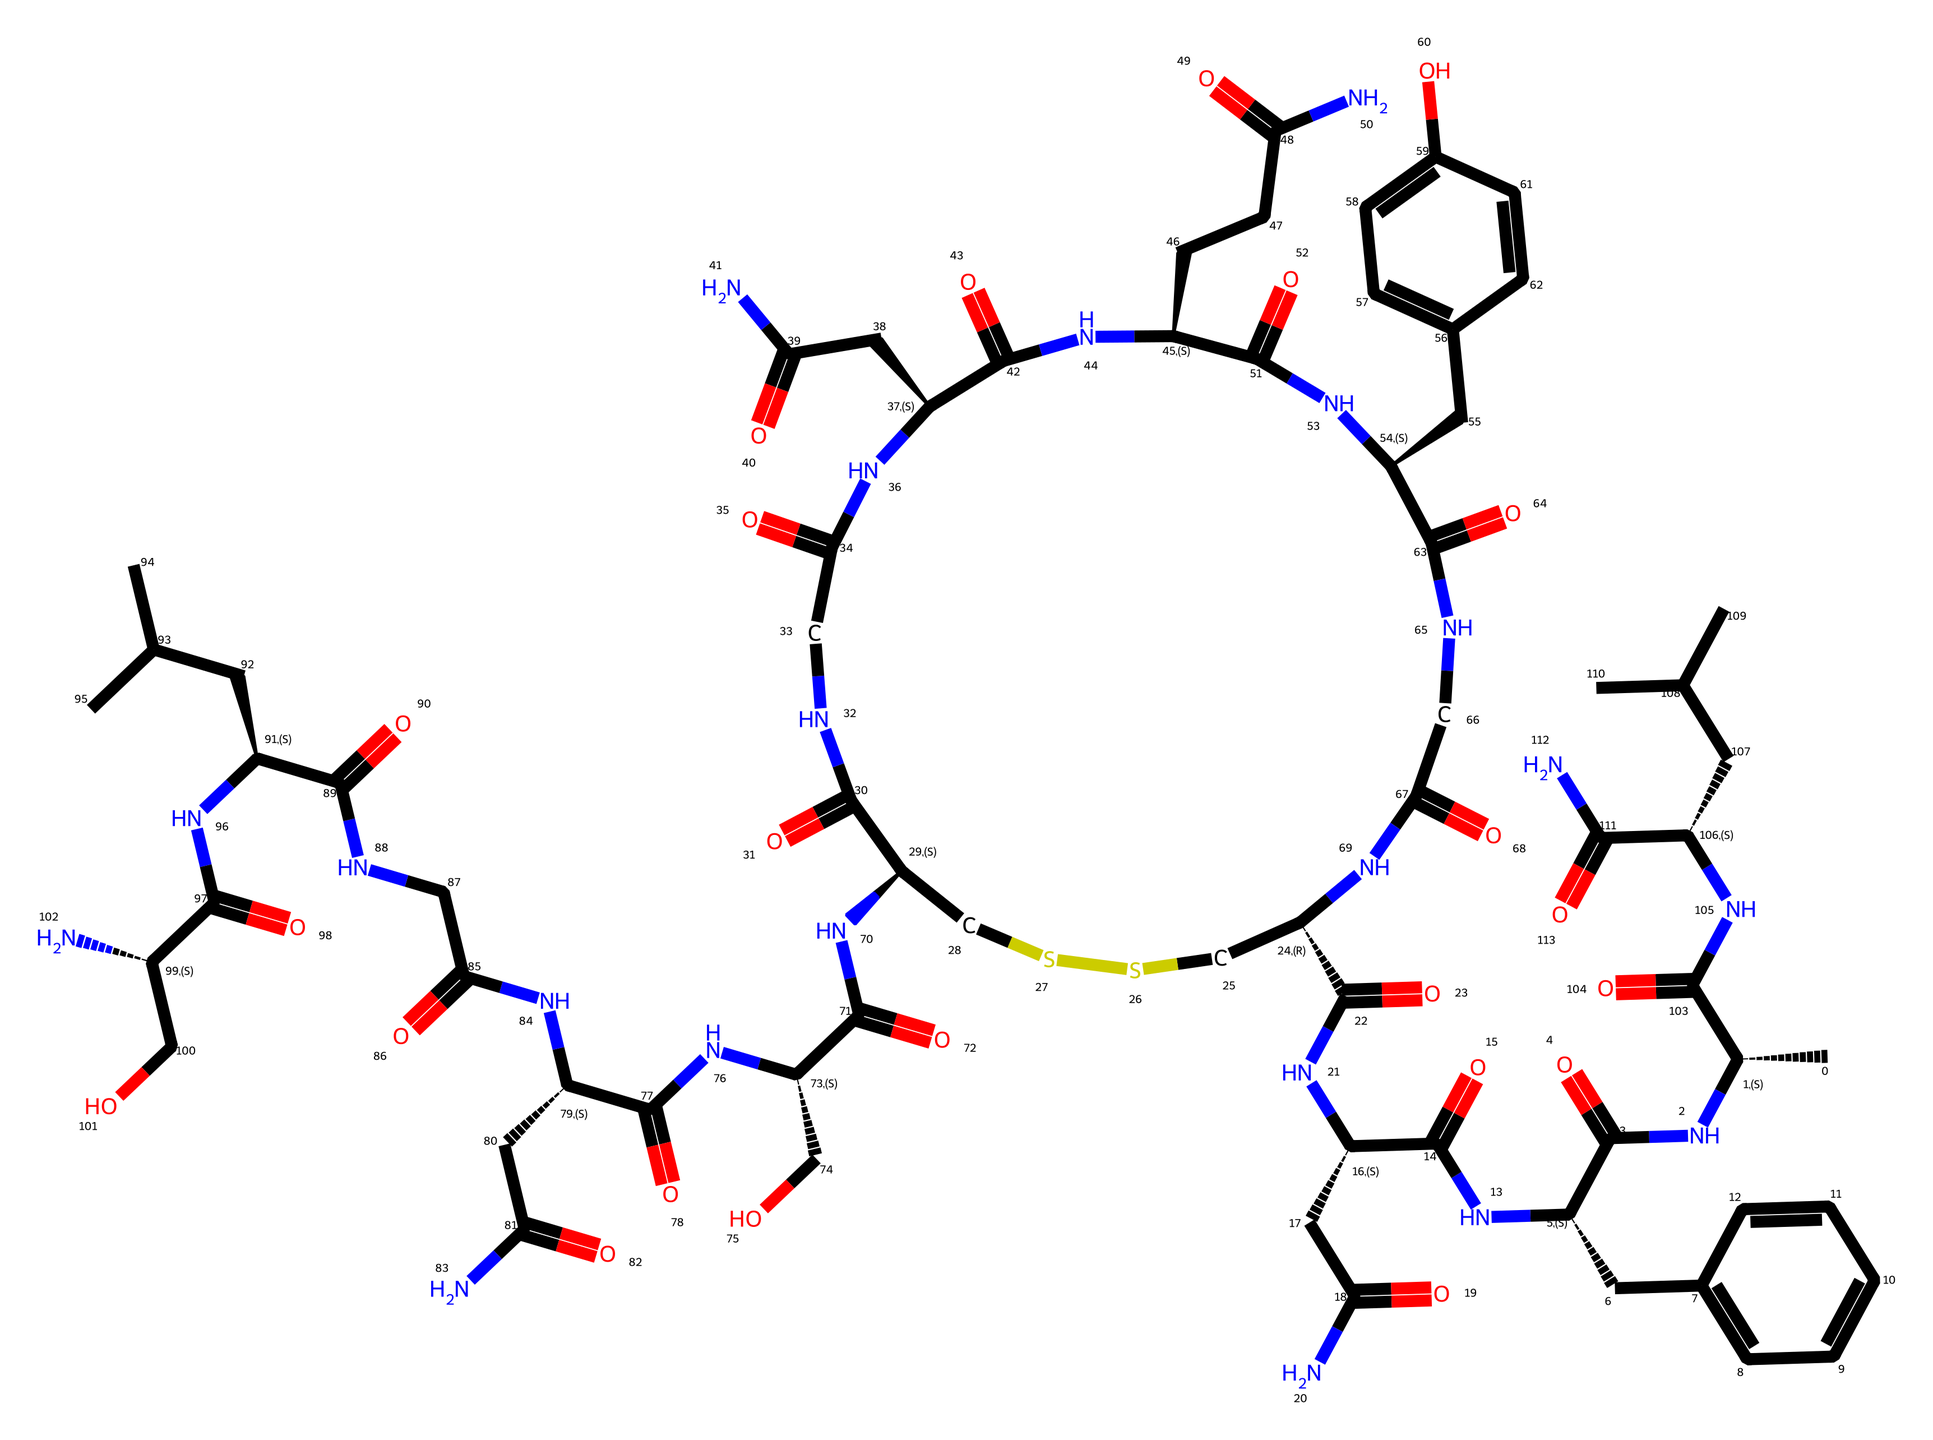What is the primary functional group present in oxytocin? The primary functional group in oxytocin is the amide (or peptide) group, identifiable by the -C(=O)N- structure that occurs multiple times throughout the molecule.
Answer: amide How many nitrogen atoms are present in this chemical? By examining the SMILES representation, we can identify nitrogen atoms, specifically looking for 'N' in the structure. There are seven nitrogen atoms in total.
Answer: seven What is the total number of carbon atoms in the molecule? Counting each carbon indicated in the SMILES code, we find multiple 'C' entries denoting carbon atoms. The total count shows there are 39 carbon atoms.
Answer: thirty-nine What type of bond does the structure predominantly feature? The structure contains a mix of single and double bonds, but due to its amide linkages and the arrangement, the predominant bond type is a single bond (C-N bonds).
Answer: single How many rings are present in the oxytocin molecule? In analyzing the SMILES representation, cyclization can be observed through the connectivity of carbon atoms that cause closed-loop structures. In oxytocin, there are two rings present.
Answer: two Is this chemical hydrophilic or hydrophobic? The presence of multiple polar functional groups, such as amides and hydroxyl groups, suggests that this molecule is hydrophilic, exhibiting a tendency to mix with water.
Answer: hydrophilic What is one function of oxytocin in human behavior? Oxytocin is often linked to enhancing bonding and social interactions. Its presence in social behavior studies highlights its role in these contexts.
Answer: bonding 